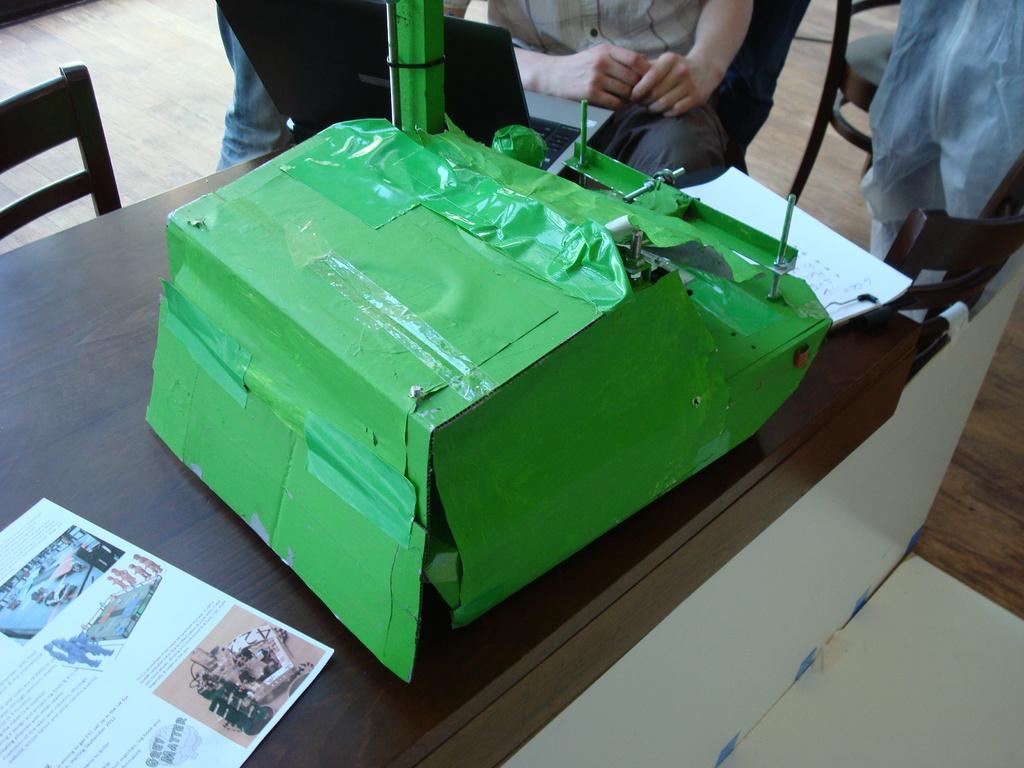Please provide a concise description of this image. In this image I can see a green colored object on a brown colored surface and on It I can see a paper. I can see few chairs around the table. I can see few persons sitting on chairs and a laptop which is black in color. 